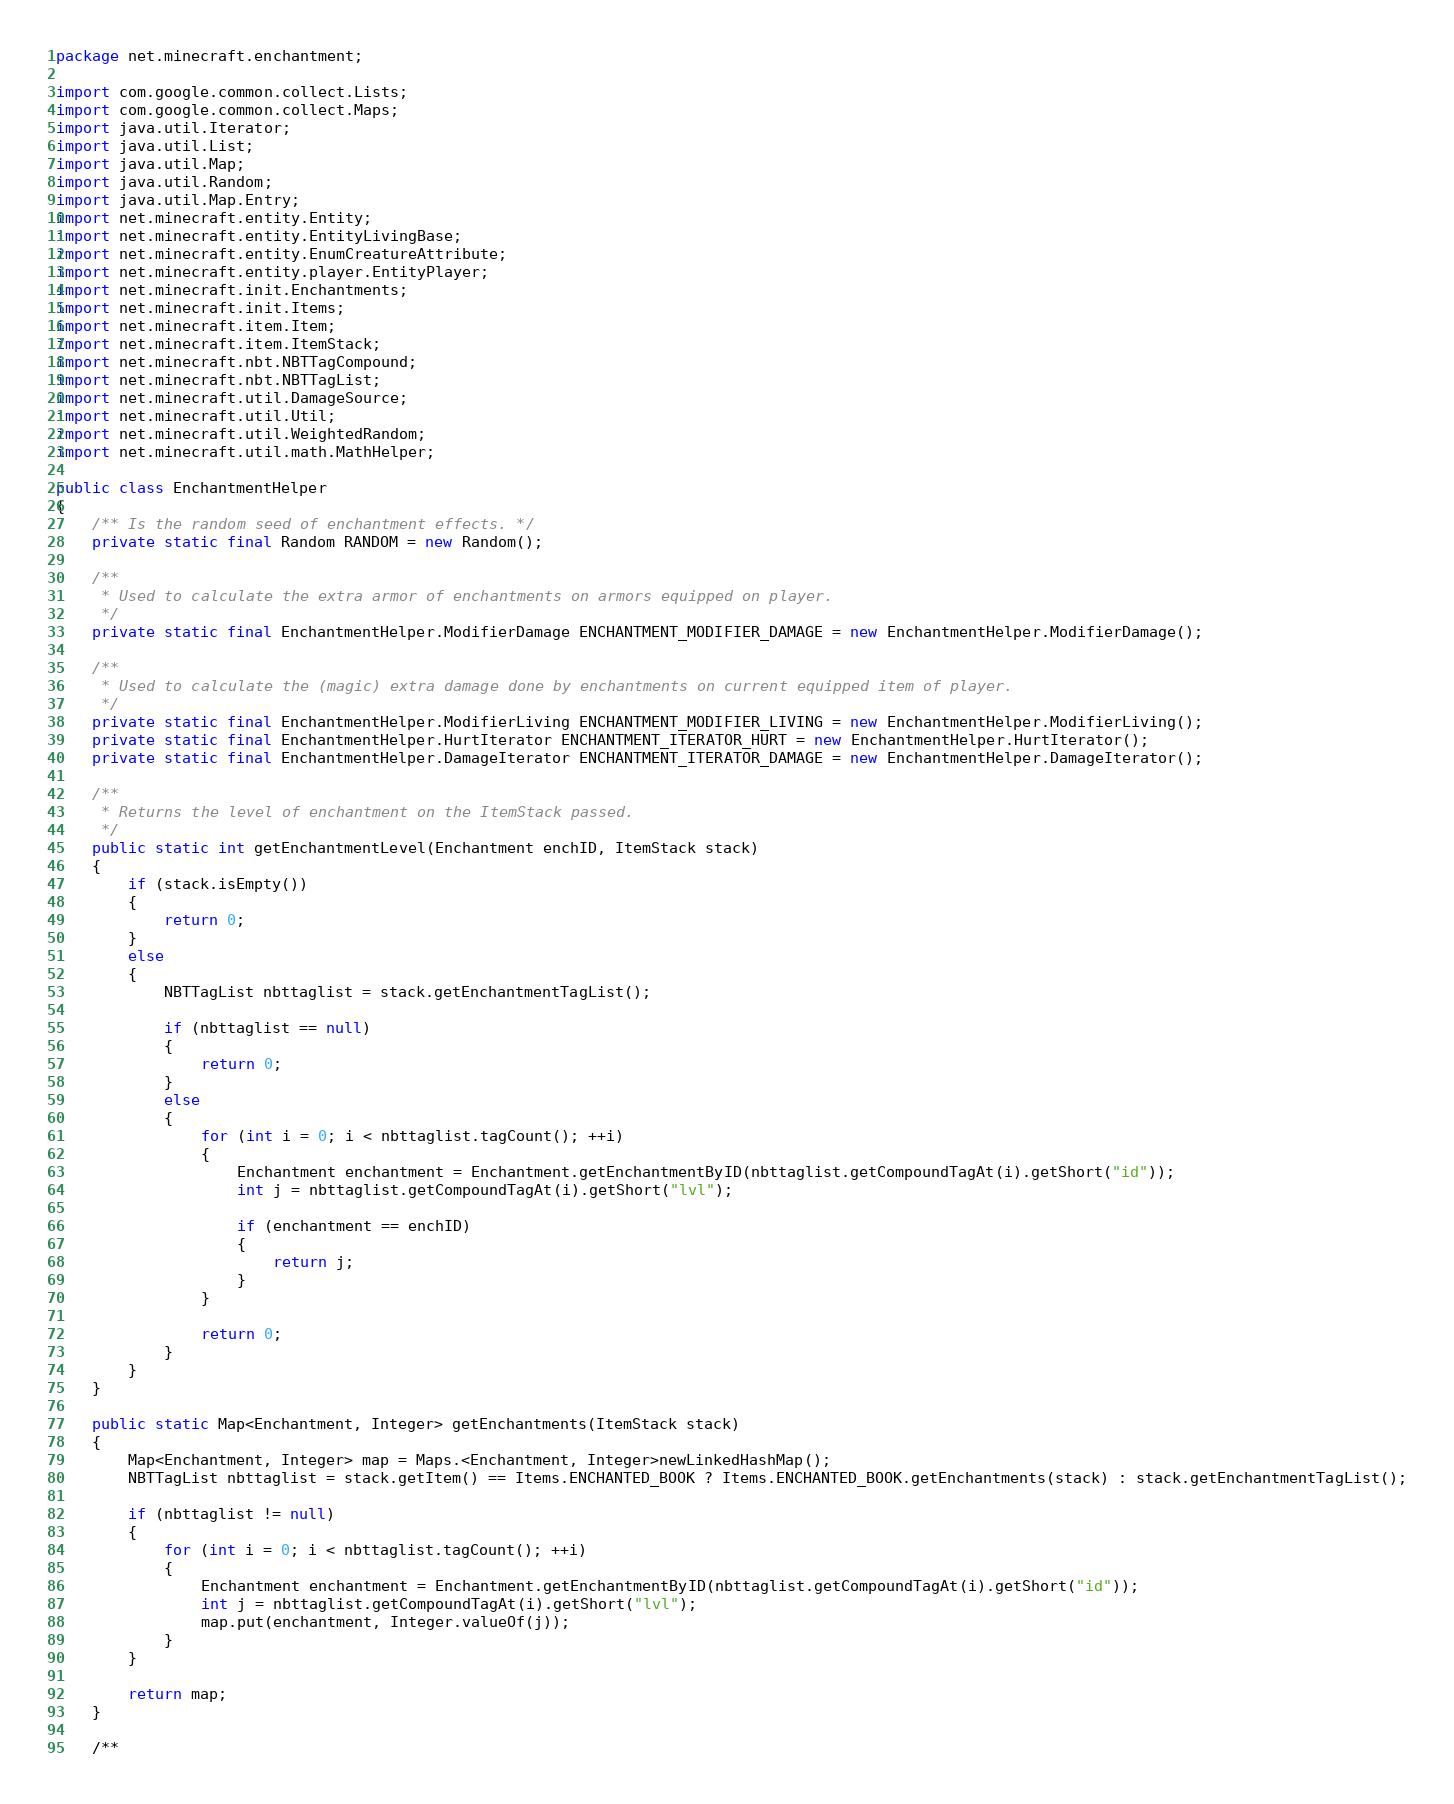<code> <loc_0><loc_0><loc_500><loc_500><_Java_>package net.minecraft.enchantment;

import com.google.common.collect.Lists;
import com.google.common.collect.Maps;
import java.util.Iterator;
import java.util.List;
import java.util.Map;
import java.util.Random;
import java.util.Map.Entry;
import net.minecraft.entity.Entity;
import net.minecraft.entity.EntityLivingBase;
import net.minecraft.entity.EnumCreatureAttribute;
import net.minecraft.entity.player.EntityPlayer;
import net.minecraft.init.Enchantments;
import net.minecraft.init.Items;
import net.minecraft.item.Item;
import net.minecraft.item.ItemStack;
import net.minecraft.nbt.NBTTagCompound;
import net.minecraft.nbt.NBTTagList;
import net.minecraft.util.DamageSource;
import net.minecraft.util.Util;
import net.minecraft.util.WeightedRandom;
import net.minecraft.util.math.MathHelper;

public class EnchantmentHelper
{
    /** Is the random seed of enchantment effects. */
    private static final Random RANDOM = new Random();

    /**
     * Used to calculate the extra armor of enchantments on armors equipped on player.
     */
    private static final EnchantmentHelper.ModifierDamage ENCHANTMENT_MODIFIER_DAMAGE = new EnchantmentHelper.ModifierDamage();

    /**
     * Used to calculate the (magic) extra damage done by enchantments on current equipped item of player.
     */
    private static final EnchantmentHelper.ModifierLiving ENCHANTMENT_MODIFIER_LIVING = new EnchantmentHelper.ModifierLiving();
    private static final EnchantmentHelper.HurtIterator ENCHANTMENT_ITERATOR_HURT = new EnchantmentHelper.HurtIterator();
    private static final EnchantmentHelper.DamageIterator ENCHANTMENT_ITERATOR_DAMAGE = new EnchantmentHelper.DamageIterator();

    /**
     * Returns the level of enchantment on the ItemStack passed.
     */
    public static int getEnchantmentLevel(Enchantment enchID, ItemStack stack)
    {
        if (stack.isEmpty())
        {
            return 0;
        }
        else
        {
            NBTTagList nbttaglist = stack.getEnchantmentTagList();

            if (nbttaglist == null)
            {
                return 0;
            }
            else
            {
                for (int i = 0; i < nbttaglist.tagCount(); ++i)
                {
                    Enchantment enchantment = Enchantment.getEnchantmentByID(nbttaglist.getCompoundTagAt(i).getShort("id"));
                    int j = nbttaglist.getCompoundTagAt(i).getShort("lvl");

                    if (enchantment == enchID)
                    {
                        return j;
                    }
                }

                return 0;
            }
        }
    }

    public static Map<Enchantment, Integer> getEnchantments(ItemStack stack)
    {
        Map<Enchantment, Integer> map = Maps.<Enchantment, Integer>newLinkedHashMap();
        NBTTagList nbttaglist = stack.getItem() == Items.ENCHANTED_BOOK ? Items.ENCHANTED_BOOK.getEnchantments(stack) : stack.getEnchantmentTagList();

        if (nbttaglist != null)
        {
            for (int i = 0; i < nbttaglist.tagCount(); ++i)
            {
                Enchantment enchantment = Enchantment.getEnchantmentByID(nbttaglist.getCompoundTagAt(i).getShort("id"));
                int j = nbttaglist.getCompoundTagAt(i).getShort("lvl");
                map.put(enchantment, Integer.valueOf(j));
            }
        }

        return map;
    }

    /**</code> 